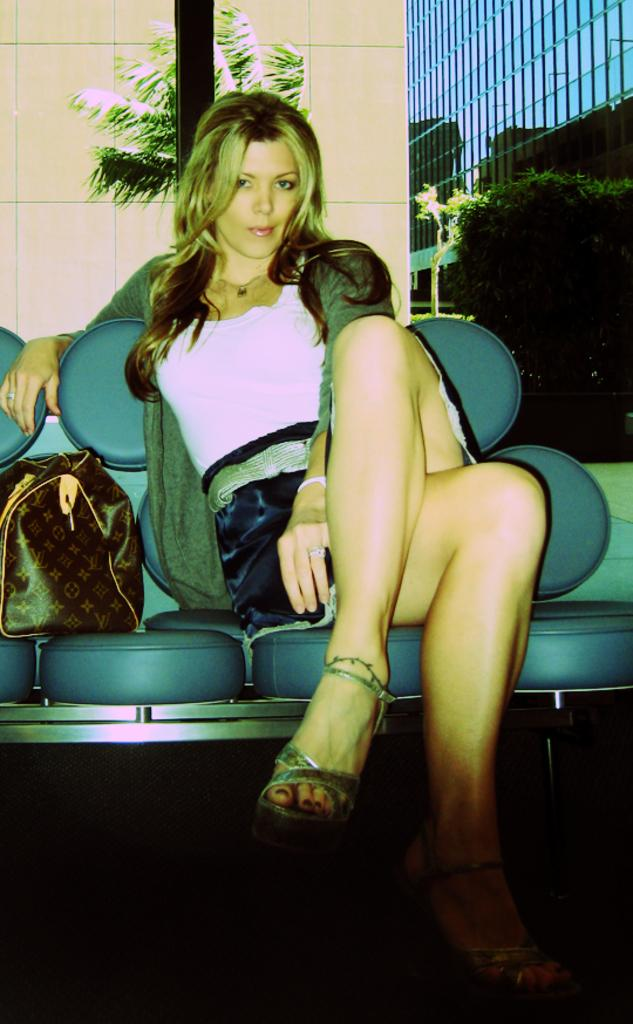What is the person in the image doing? There is a person sitting in the image. What object is to the left of the person? There is a bag to the left of the person. What type of structures can be seen in the image? There are buildings visible in the image. What type of vegetation can be seen in the image? There are trees visible in the image. What type of sail can be seen on the person's clothing in the image? There is no sail present on the person's clothing in the image. What type of plastic material is visible in the image? The provided facts do not mention any plastic material being visible in the image. 